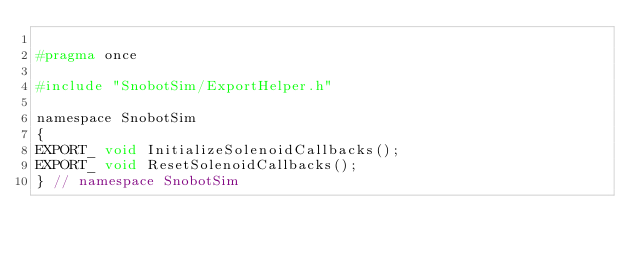Convert code to text. <code><loc_0><loc_0><loc_500><loc_500><_C_>
#pragma once

#include "SnobotSim/ExportHelper.h"

namespace SnobotSim
{
EXPORT_ void InitializeSolenoidCallbacks();
EXPORT_ void ResetSolenoidCallbacks();
} // namespace SnobotSim
</code> 